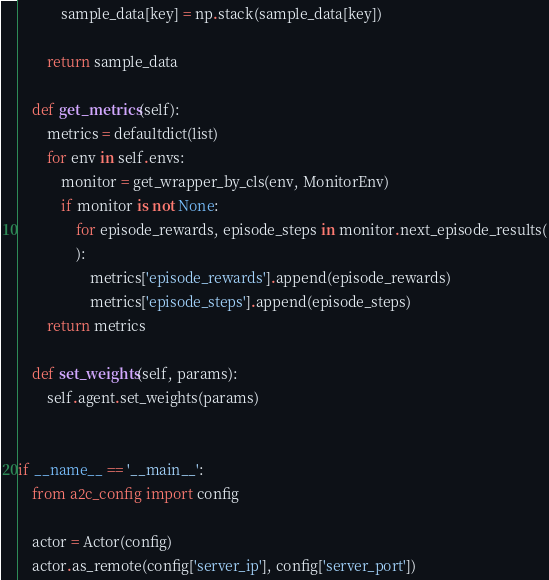<code> <loc_0><loc_0><loc_500><loc_500><_Python_>            sample_data[key] = np.stack(sample_data[key])

        return sample_data

    def get_metrics(self):
        metrics = defaultdict(list)
        for env in self.envs:
            monitor = get_wrapper_by_cls(env, MonitorEnv)
            if monitor is not None:
                for episode_rewards, episode_steps in monitor.next_episode_results(
                ):
                    metrics['episode_rewards'].append(episode_rewards)
                    metrics['episode_steps'].append(episode_steps)
        return metrics

    def set_weights(self, params):
        self.agent.set_weights(params)


if __name__ == '__main__':
    from a2c_config import config

    actor = Actor(config)
    actor.as_remote(config['server_ip'], config['server_port'])
</code> 